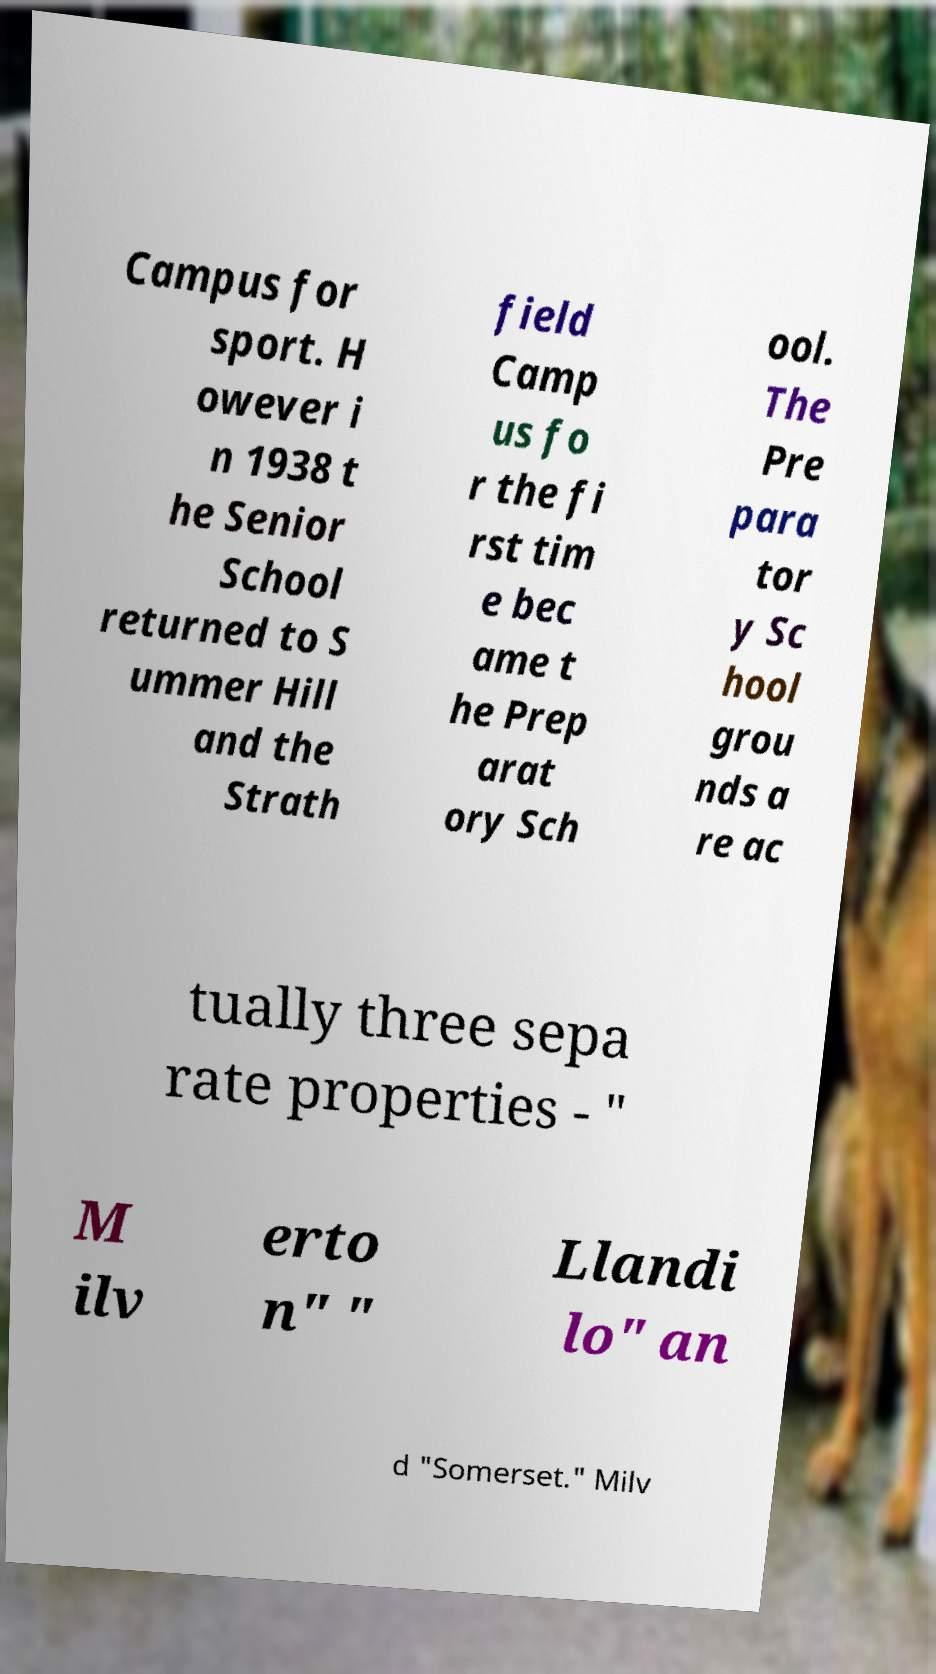There's text embedded in this image that I need extracted. Can you transcribe it verbatim? Campus for sport. H owever i n 1938 t he Senior School returned to S ummer Hill and the Strath field Camp us fo r the fi rst tim e bec ame t he Prep arat ory Sch ool. The Pre para tor y Sc hool grou nds a re ac tually three sepa rate properties - " M ilv erto n" " Llandi lo" an d "Somerset." Milv 